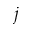Convert formula to latex. <formula><loc_0><loc_0><loc_500><loc_500>j</formula> 